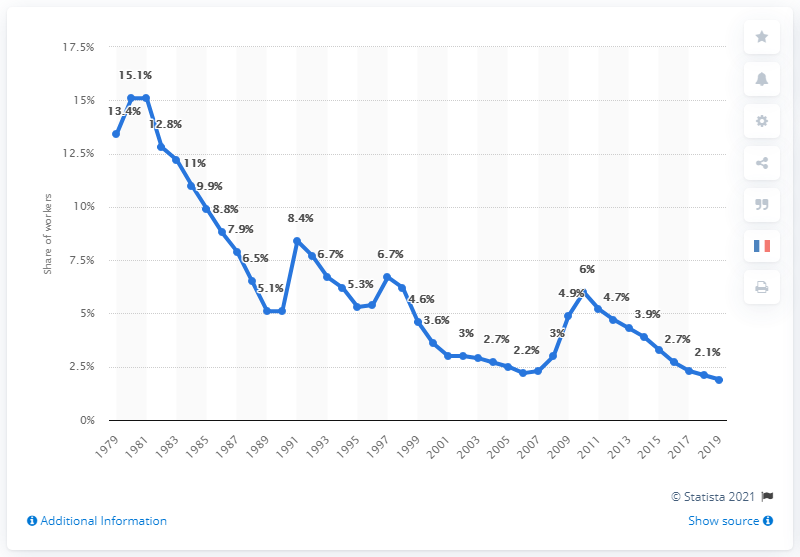Identify some key points in this picture. In 2019, approximately 1.9% of workers were paid less than the minimum wage. 